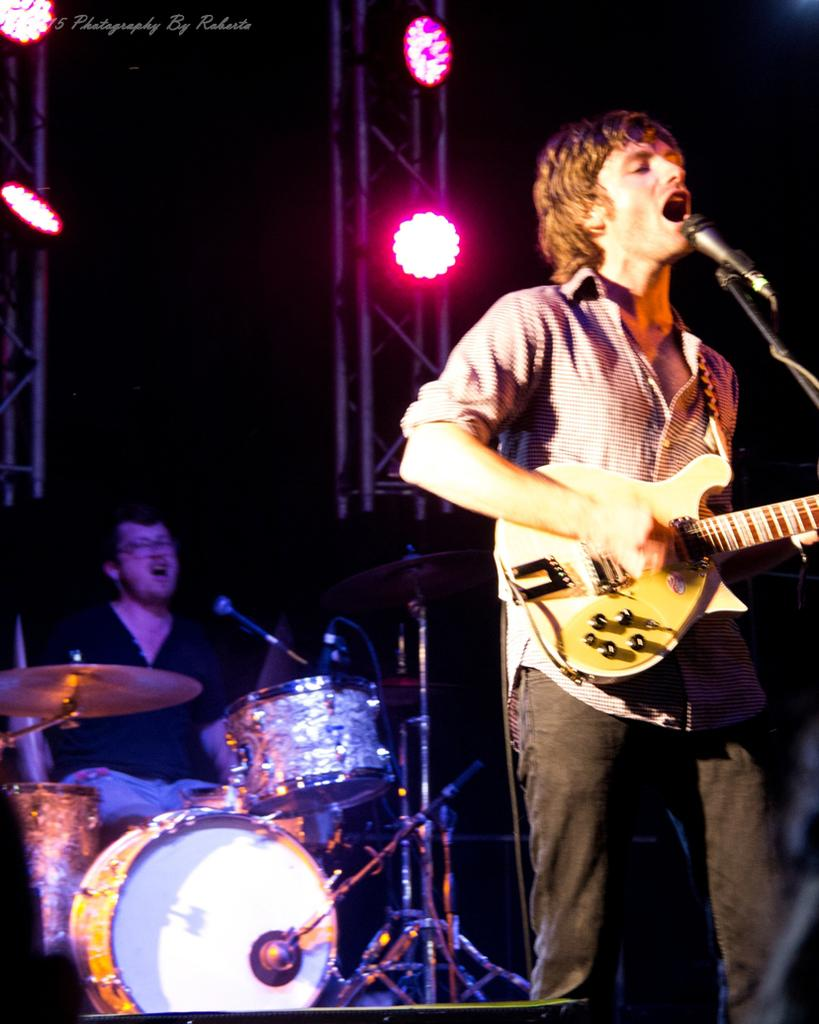What is the person in the image doing? The person is holding a guitar and playing and singing. What is in front of the person playing the guitar? There is a microphone in front of the person playing the guitar. What instrument is being played by the person in the background? The person in the background is playing drums. What can be seen in the background of the image? There are lights visible in the background. Can you see any toads at the zoo in the image? There is no mention of a zoo or toads in the image; it features a person playing the guitar and a person playing drums. 